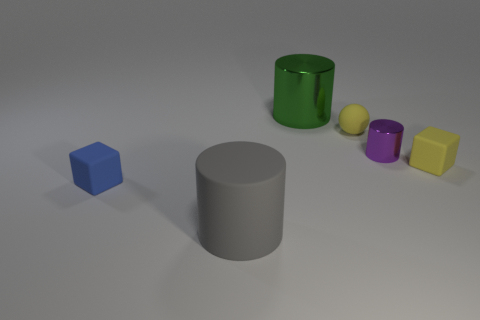Subtract all big gray matte cylinders. How many cylinders are left? 2 Add 3 large purple rubber cylinders. How many objects exist? 9 Subtract all purple cylinders. How many cylinders are left? 2 Subtract 1 blocks. How many blocks are left? 1 Add 6 small purple metal cylinders. How many small purple metal cylinders exist? 7 Subtract 0 red balls. How many objects are left? 6 Subtract all spheres. How many objects are left? 5 Subtract all cyan cylinders. Subtract all purple balls. How many cylinders are left? 3 Subtract all gray spheres. How many green cylinders are left? 1 Subtract all rubber spheres. Subtract all rubber things. How many objects are left? 1 